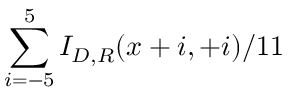<formula> <loc_0><loc_0><loc_500><loc_500>\sum _ { i = - 5 } ^ { 5 } I _ { D , R } ( x + i , + i ) / 1 1</formula> 